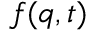Convert formula to latex. <formula><loc_0><loc_0><loc_500><loc_500>f ( q , t )</formula> 